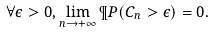Convert formula to latex. <formula><loc_0><loc_0><loc_500><loc_500>\forall \epsilon > 0 , \lim _ { n \to + \infty } \P P ( C _ { n } > \epsilon ) = 0 .</formula> 